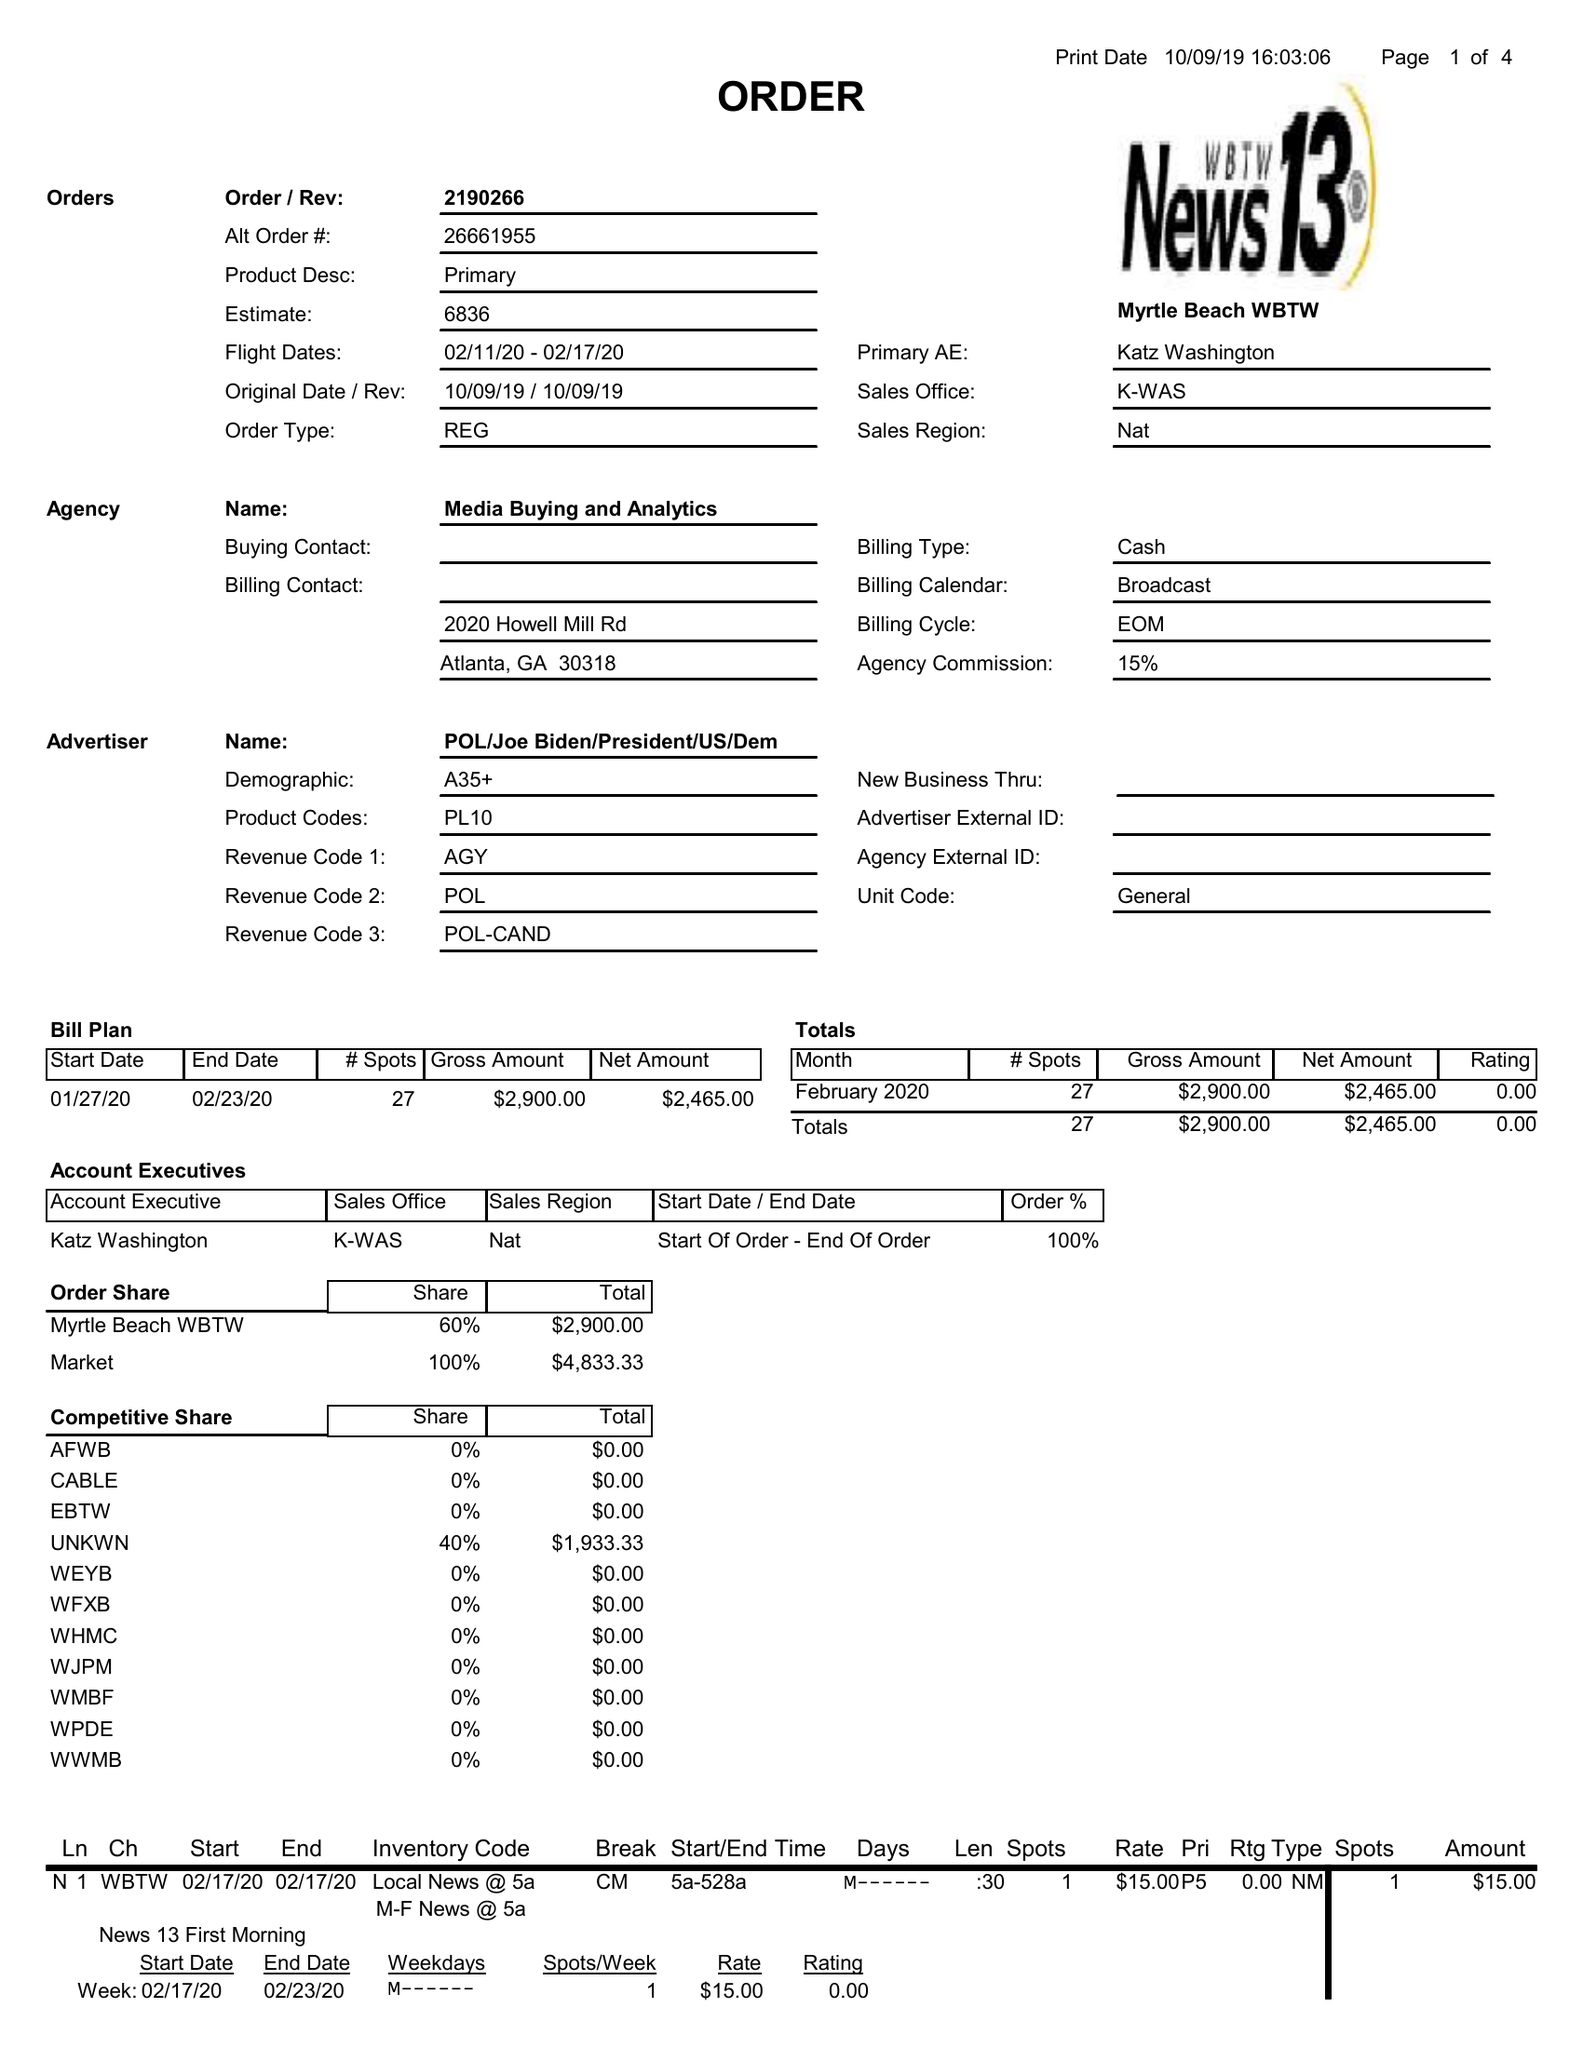What is the value for the flight_to?
Answer the question using a single word or phrase. 02/17/20 